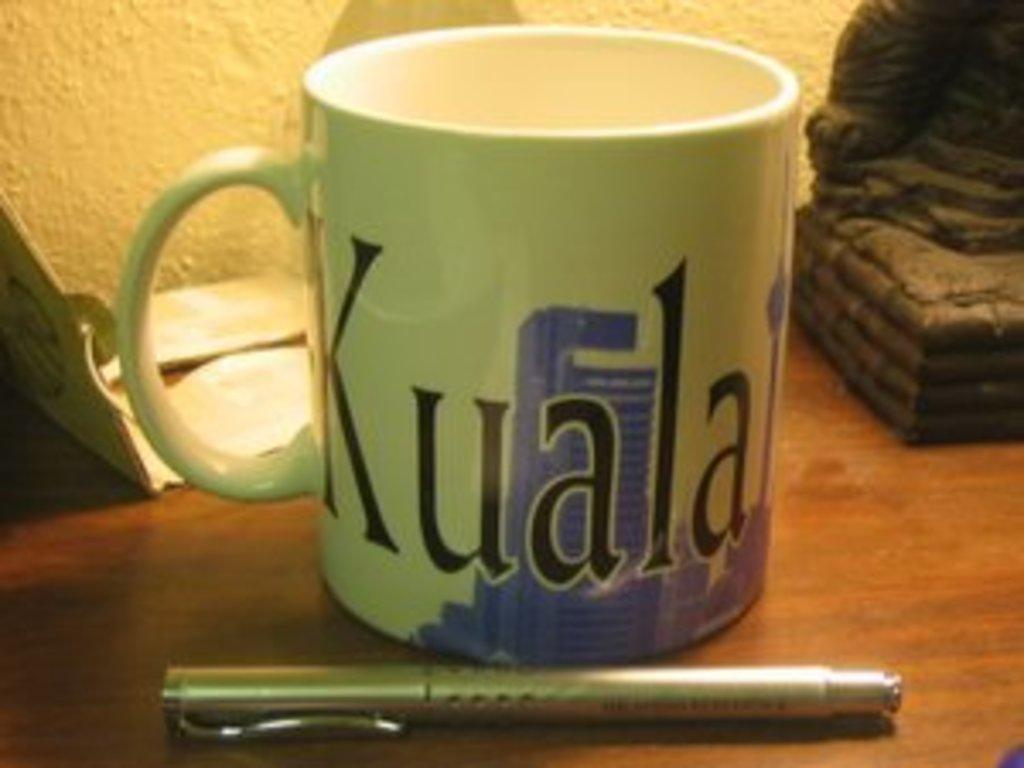What piece of furniture is visible in the image? There is a table in the image. What is on the table? A cup and a pen are on the table. Are there any other objects on the table? Yes, there are other objects on the table. What can be seen in the background of the image? There is a wall in the background of the image. What type of hair is visible on the table in the image? There is no hair visible on the table in the image. What is the value of the dime on the table in the image? There is no dime present on the table in the image. 